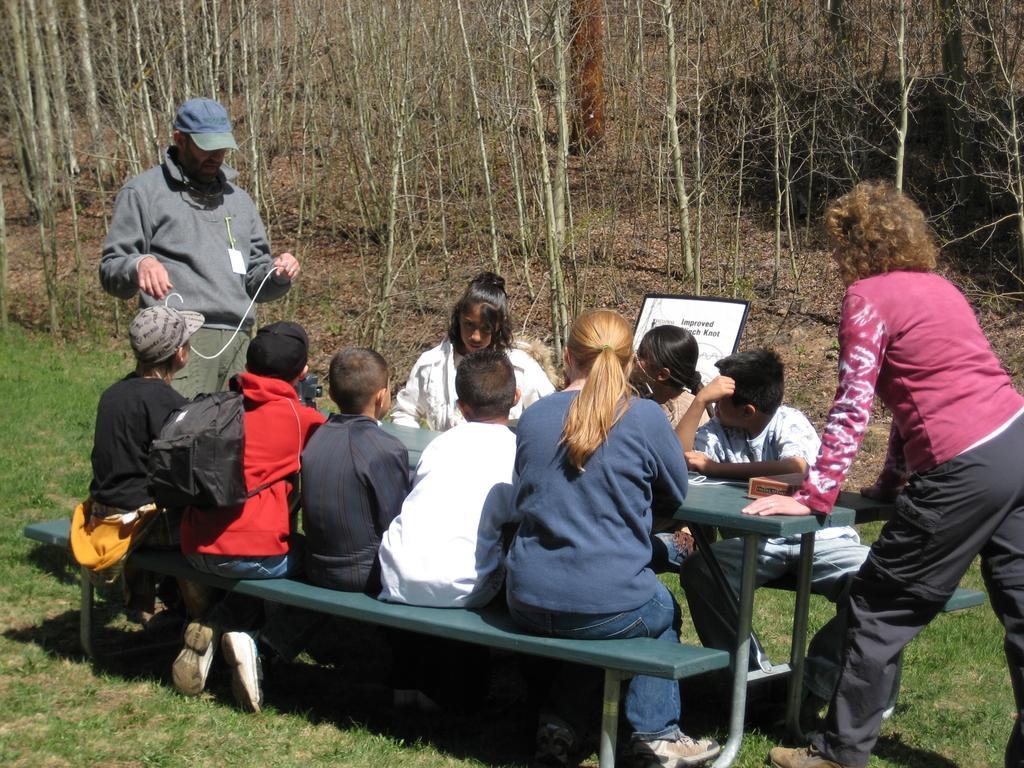Please provide a concise description of this image. In this image there are so many children and lady sitting on bench which is on grass field, where a man and woman standing, beside them there are so many trees. 